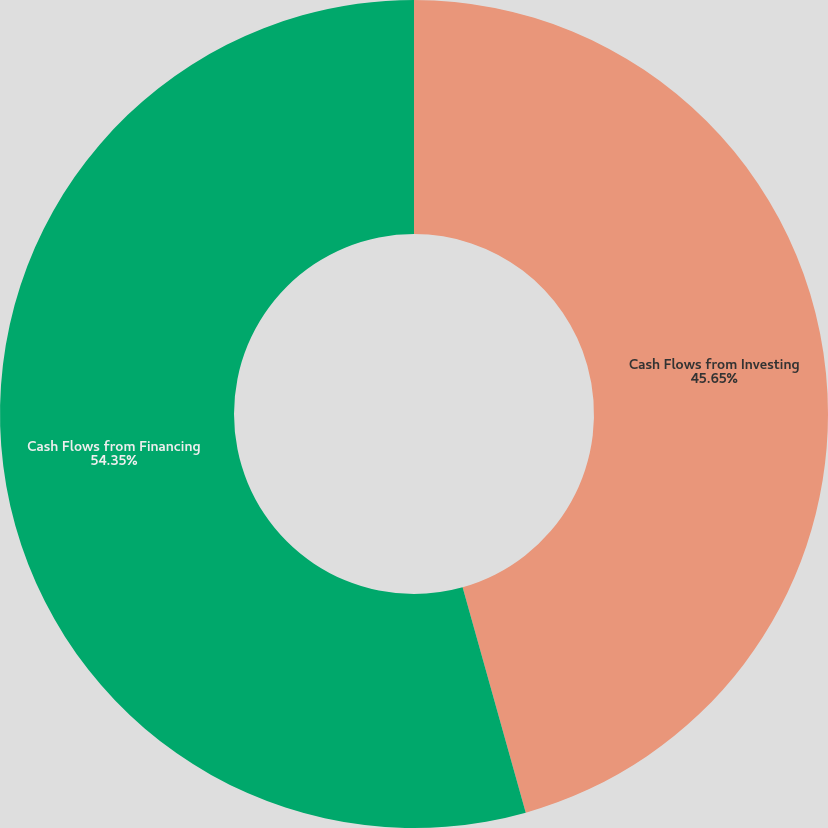<chart> <loc_0><loc_0><loc_500><loc_500><pie_chart><fcel>Cash Flows from Investing<fcel>Cash Flows from Financing<nl><fcel>45.65%<fcel>54.35%<nl></chart> 